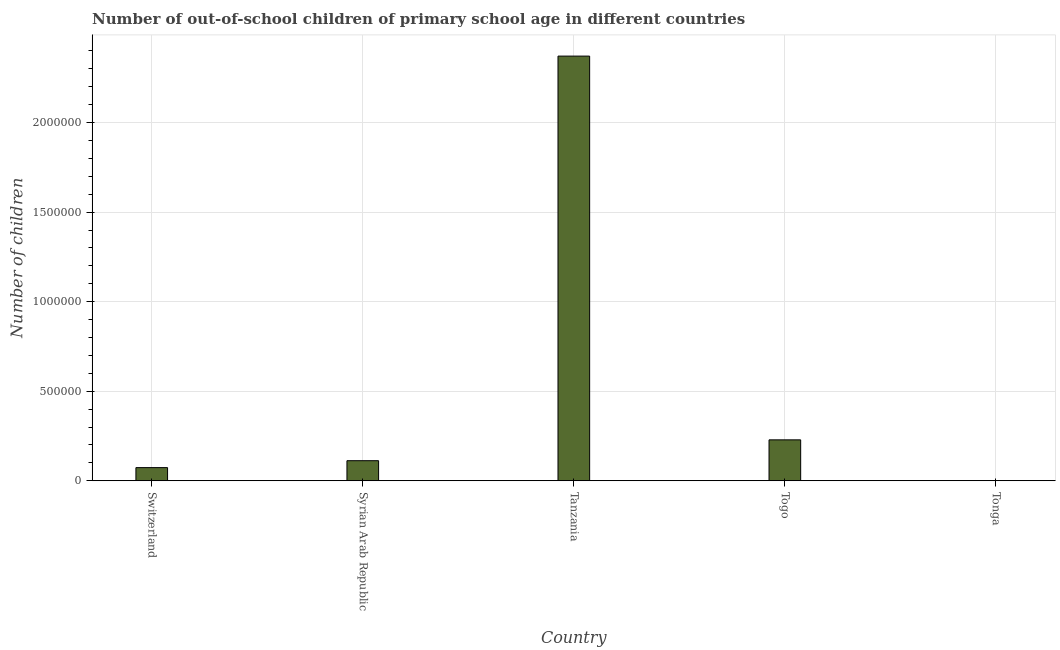Does the graph contain any zero values?
Give a very brief answer. No. What is the title of the graph?
Offer a terse response. Number of out-of-school children of primary school age in different countries. What is the label or title of the Y-axis?
Keep it short and to the point. Number of children. What is the number of out-of-school children in Switzerland?
Keep it short and to the point. 7.35e+04. Across all countries, what is the maximum number of out-of-school children?
Keep it short and to the point. 2.37e+06. Across all countries, what is the minimum number of out-of-school children?
Provide a short and direct response. 1188. In which country was the number of out-of-school children maximum?
Your answer should be very brief. Tanzania. In which country was the number of out-of-school children minimum?
Provide a succinct answer. Tonga. What is the sum of the number of out-of-school children?
Make the answer very short. 2.79e+06. What is the difference between the number of out-of-school children in Syrian Arab Republic and Tonga?
Provide a succinct answer. 1.11e+05. What is the average number of out-of-school children per country?
Provide a succinct answer. 5.57e+05. What is the median number of out-of-school children?
Give a very brief answer. 1.12e+05. In how many countries, is the number of out-of-school children greater than 2200000 ?
Provide a short and direct response. 1. What is the ratio of the number of out-of-school children in Switzerland to that in Tonga?
Make the answer very short. 61.85. What is the difference between the highest and the second highest number of out-of-school children?
Make the answer very short. 2.14e+06. What is the difference between the highest and the lowest number of out-of-school children?
Keep it short and to the point. 2.37e+06. How many countries are there in the graph?
Make the answer very short. 5. Are the values on the major ticks of Y-axis written in scientific E-notation?
Offer a terse response. No. What is the Number of children in Switzerland?
Offer a very short reply. 7.35e+04. What is the Number of children of Syrian Arab Republic?
Offer a very short reply. 1.12e+05. What is the Number of children in Tanzania?
Give a very brief answer. 2.37e+06. What is the Number of children of Togo?
Your answer should be compact. 2.29e+05. What is the Number of children of Tonga?
Keep it short and to the point. 1188. What is the difference between the Number of children in Switzerland and Syrian Arab Republic?
Give a very brief answer. -3.87e+04. What is the difference between the Number of children in Switzerland and Tanzania?
Your answer should be compact. -2.30e+06. What is the difference between the Number of children in Switzerland and Togo?
Make the answer very short. -1.55e+05. What is the difference between the Number of children in Switzerland and Tonga?
Make the answer very short. 7.23e+04. What is the difference between the Number of children in Syrian Arab Republic and Tanzania?
Your answer should be compact. -2.26e+06. What is the difference between the Number of children in Syrian Arab Republic and Togo?
Your answer should be compact. -1.16e+05. What is the difference between the Number of children in Syrian Arab Republic and Tonga?
Provide a succinct answer. 1.11e+05. What is the difference between the Number of children in Tanzania and Togo?
Your response must be concise. 2.14e+06. What is the difference between the Number of children in Tanzania and Tonga?
Offer a very short reply. 2.37e+06. What is the difference between the Number of children in Togo and Tonga?
Your answer should be very brief. 2.27e+05. What is the ratio of the Number of children in Switzerland to that in Syrian Arab Republic?
Ensure brevity in your answer.  0.66. What is the ratio of the Number of children in Switzerland to that in Tanzania?
Ensure brevity in your answer.  0.03. What is the ratio of the Number of children in Switzerland to that in Togo?
Your answer should be very brief. 0.32. What is the ratio of the Number of children in Switzerland to that in Tonga?
Ensure brevity in your answer.  61.85. What is the ratio of the Number of children in Syrian Arab Republic to that in Tanzania?
Provide a short and direct response. 0.05. What is the ratio of the Number of children in Syrian Arab Republic to that in Togo?
Your response must be concise. 0.49. What is the ratio of the Number of children in Syrian Arab Republic to that in Tonga?
Your answer should be very brief. 94.41. What is the ratio of the Number of children in Tanzania to that in Togo?
Make the answer very short. 10.37. What is the ratio of the Number of children in Tanzania to that in Tonga?
Provide a short and direct response. 1995.71. What is the ratio of the Number of children in Togo to that in Tonga?
Offer a terse response. 192.4. 